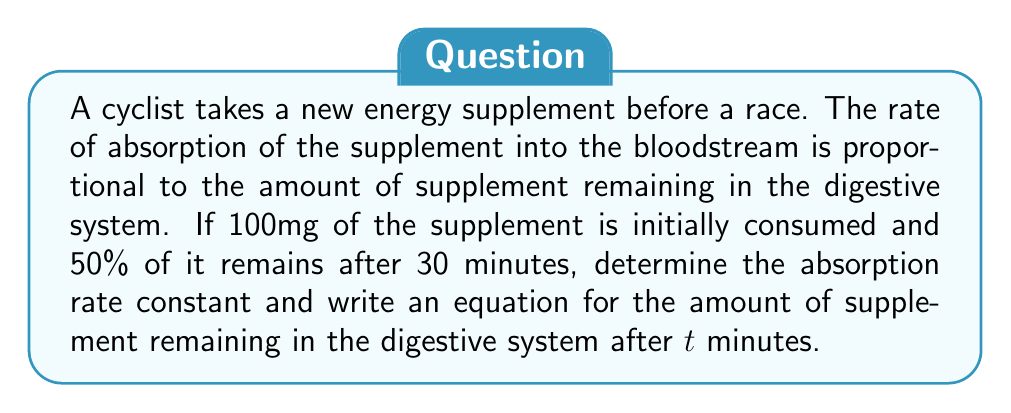Help me with this question. Let's approach this step-by-step:

1) Let $A(t)$ be the amount of supplement remaining in the digestive system at time $t$ (in minutes).

2) The rate of change of $A$ with respect to $t$ is proportional to $A$:

   $$\frac{dA}{dt} = -kA$$

   where $k$ is the absorption rate constant (per minute).

3) This differential equation has the general solution:

   $$A(t) = A_0e^{-kt}$$

   where $A_0$ is the initial amount of supplement.

4) We know:
   - $A_0 = 100$ mg
   - At $t = 30$ minutes, $A(30) = 50$ mg (50% of 100 mg)

5) Substituting these values:

   $$50 = 100e^{-30k}$$

6) Solving for $k$:

   $$\frac{1}{2} = e^{-30k}$$
   $$\ln(\frac{1}{2}) = -30k$$
   $$k = -\frac{\ln(\frac{1}{2})}{30} \approx 0.0231 \text{ per minute}$$

7) Therefore, the equation for the amount of supplement remaining is:

   $$A(t) = 100e^{-0.0231t}$$
Answer: $k \approx 0.0231 \text{ min}^{-1}$, $A(t) = 100e^{-0.0231t}$ mg 